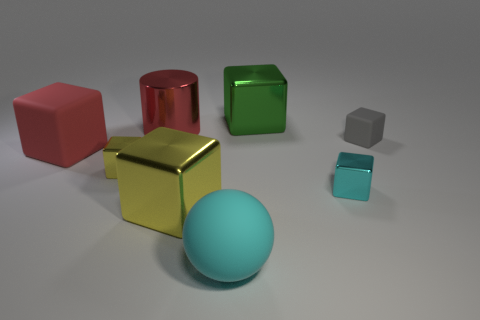Subtract all big green metal cubes. How many cubes are left? 5 Subtract all red cubes. How many cubes are left? 5 Subtract all blue spheres. Subtract all purple cubes. How many spheres are left? 1 Add 1 big cyan rubber things. How many objects exist? 9 Subtract all blocks. How many objects are left? 2 Add 8 big yellow metallic things. How many big yellow metallic things exist? 9 Subtract 0 green spheres. How many objects are left? 8 Subtract all tiny matte cubes. Subtract all big red things. How many objects are left? 5 Add 3 small matte things. How many small matte things are left? 4 